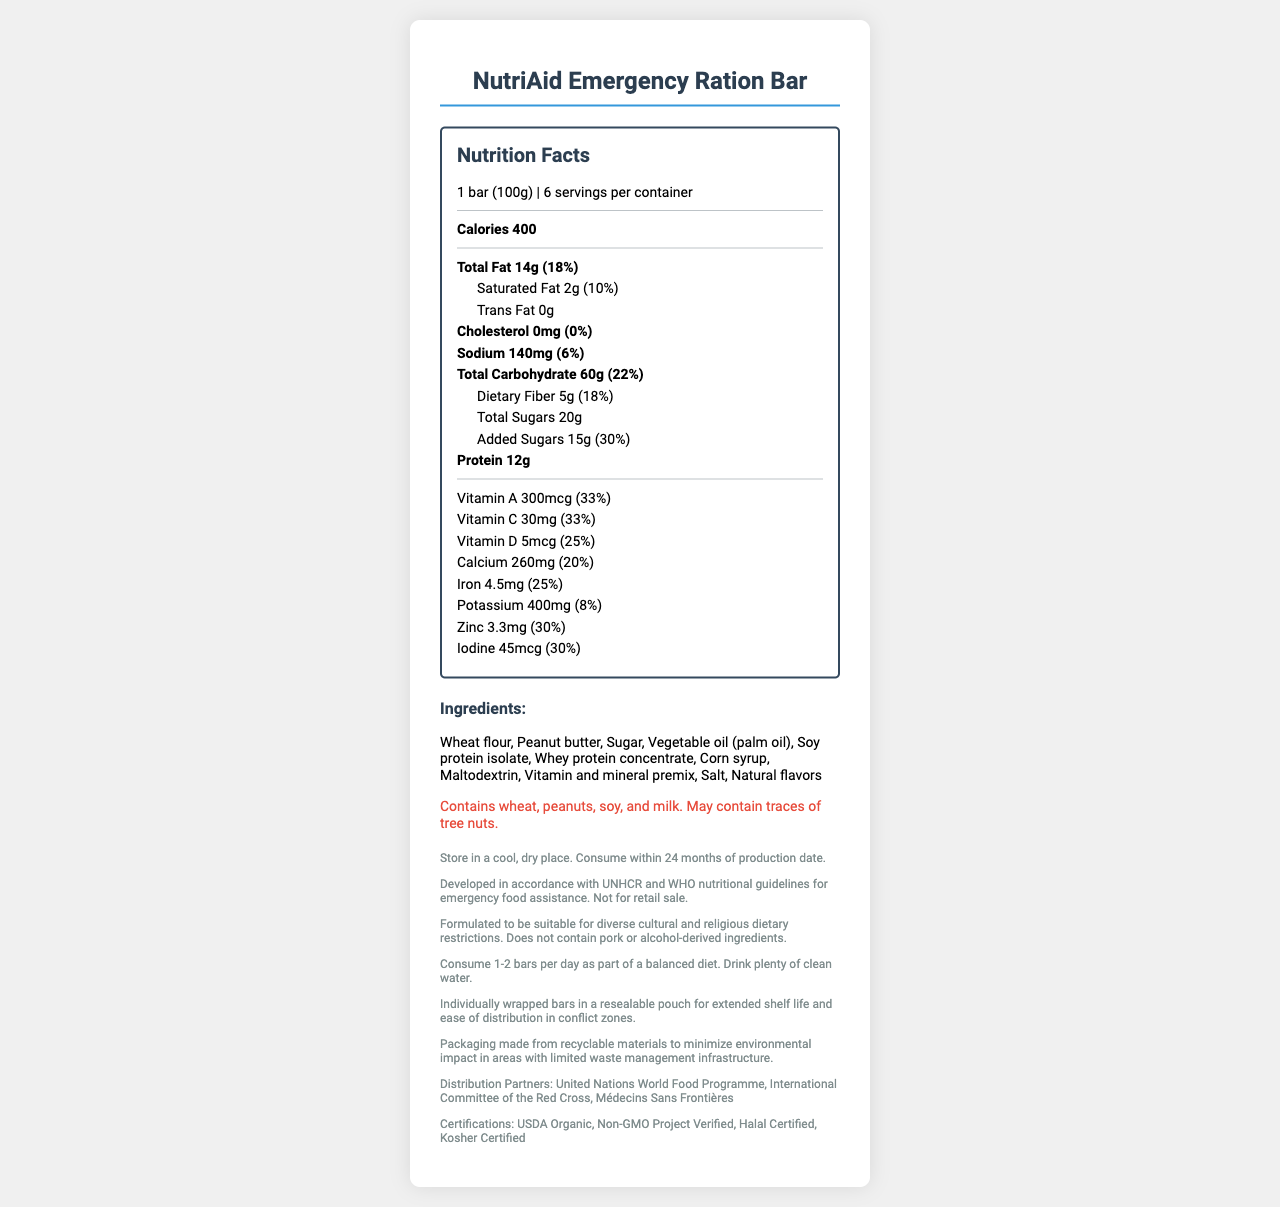How many servings are there per container? The document states that there are 6 servings per container.
Answer: 6 What is the serving size of the NutriAid Emergency Ration Bar? The document specifies that the serving size is 1 bar (100g).
Answer: 1 bar (100g) How many calories are there in one serving? According to the document, one serving contains 400 calories.
Answer: 400 What is the total amount of fat in one serving, and what percentage of the daily value does it represent? The document indicates that the total fat per serving is 14g, which is 18% of the daily value.
Answer: 14g, 18% What amount of dietary fiber does one serving contain? The document lists the dietary fiber amount as 5g per serving.
Answer: 5g Which vitamins and minerals are most abundant in one serving of the NutriAid Emergency Ration Bar based on their daily values percentages? A. Vitamin A and Vitamin C B. Vitamin D and Calcium C. Zinc and Iodine D. All of the above The document lists the daily value percentages for Vitamin A, Vitamin C, Zinc, and Iodine all as 30% or higher.
Answer: D Does this product contain any trans fat? The document states that the content of trans fat is 0g.
Answer: No What allergens are present in the NutriAid Emergency Ration Bar? A. Wheat, peanuts, soy B. Peanuts, tree nuts, milk C. Soy, milk, eggs D. Tree nuts, wheat, soy The allergen information section lists wheat, peanuts, soy, and milk as allergens.
Answer: A Is the NutriAid Emergency Ration Bar suitable for consumption by people with religious dietary restrictions? The document mentions that the product is formulated to be suitable for diverse cultural and religious dietary restrictions and does not contain pork or alcohol-derived ingredients.
Answer: Yes What instruction is given regarding water consumption with the NutriAid Emergency Ration Bar? The usage instructions section advises consuming plenty of clean water along with the product.
Answer: Drink plenty of clean water Summarize the main idea of the document. The document details the nutritional information, ingredients, allergen warnings, usage instructions, and suitability for different cultural and religious diets. It also mentions storage instructions, packaging benefits, and distribution partners.
Answer: The NutriAid Emergency Ration Bar is a fortified food product designed for humanitarian aid in conflict zones. It provides essential nutrients, meets various dietary restrictions, and is certified by recognized organizations. The packaging ensures long shelf life and ease of distribution. What is the production date shelf life for the NutriAid Emergency Ration Bar? The storage instructions specify that the product should be consumed within 24 months of the production date.
Answer: 24 months Which organizations are the distribution partners for the NutriAid Emergency Ration Bar? The document lists these three organizations as distribution partners.
Answer: United Nations World Food Programme, International Committee of the Red Cross, Médecins Sans Frontières Can the NutriAid Emergency Ration Bar be purchased at retail stores? The legal disclaimer states that the product is not for retail sale.
Answer: No What are the certifications held by the NutriAid Emergency Ration Bar? The document lists these certifications in the additional information section.
Answer: USDA Organic, Non-GMO Project Verified, Halal Certified, Kosher Certified Explain the "sustainability note" mentioned in the document. The document indicates that the packaging is designed to be environmentally friendly due to the use of recyclable materials.
Answer: The packaging is made from recyclable materials to minimize environmental impact in areas with limited waste management infrastructure. What is the total sugar content (including added sugars) in one serving of the NutriAid Emergency Ration Bar? The document specifies 20g of total sugars and 15g of added sugars in one serving.
Answer: 20g total sugars, 15g added sugars What are the primary sources of protein in the NutriAid Emergency Ration Bar? The ingredients list includes soy protein isolate and whey protein concentrate as primary sources of protein.
Answer: Soy protein isolate, whey protein concentrate 